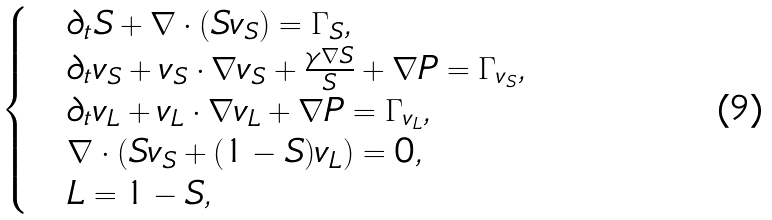<formula> <loc_0><loc_0><loc_500><loc_500>\begin{cases} & \partial _ { t } S + \nabla \cdot ( S v _ { S } ) = \Gamma _ { S } , \\ & \partial _ { t } { v } _ { S } + { v } _ { S } \cdot \nabla { v } _ { S } + \frac { \gamma \nabla S } { S } + \nabla { P } = \Gamma _ { v _ { S } } , \\ & \partial _ { t } { v } _ { L } + { v } _ { L } \cdot \nabla { v } _ { L } + \nabla { P } = \Gamma _ { v _ { L } } , \\ & \nabla \cdot ( S v _ { S } + ( 1 - S ) v _ { L } ) = 0 , \\ & L = 1 - S , \end{cases}</formula> 